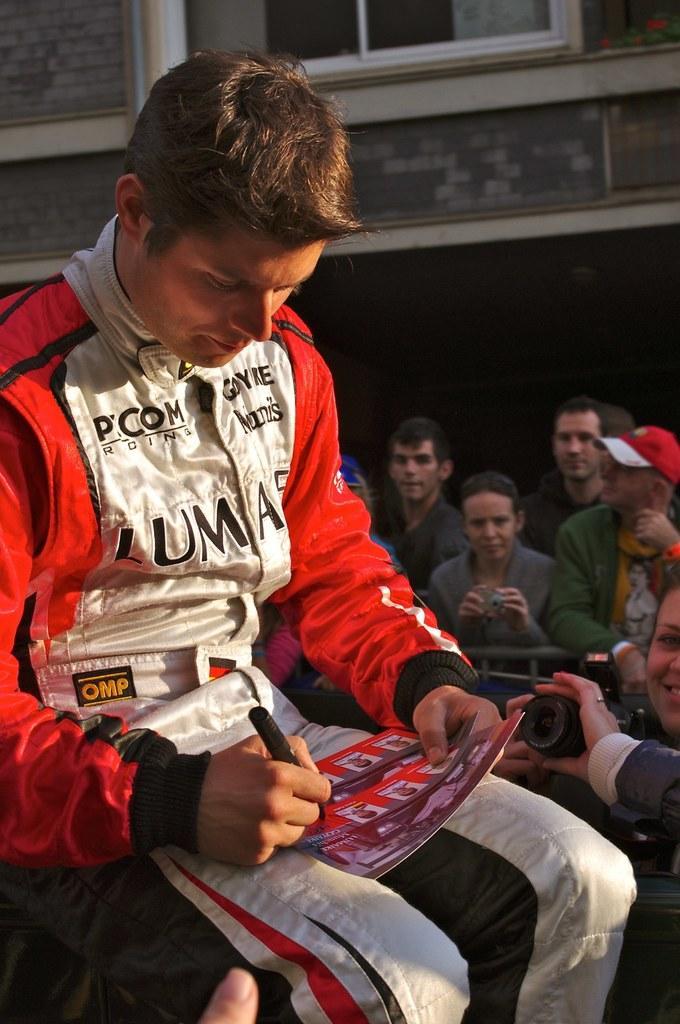Could you give a brief overview of what you see in this image? In this picture I can see there is a man sitting and he is wearing a red shirt and a white pant. He is writing something on the paper and there are many people standing around him. In the backdrop there is a wall and there is a window. 